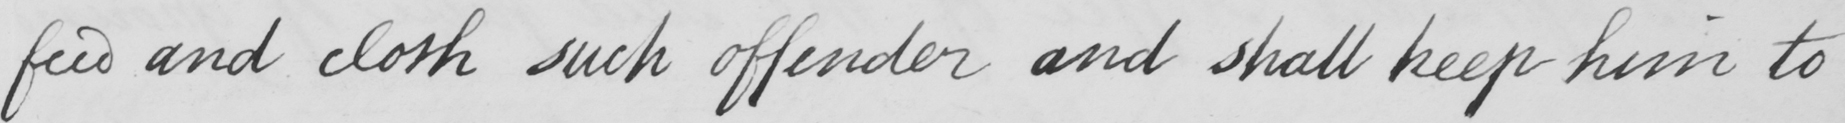Transcribe the text shown in this historical manuscript line. feed and cloth such offender and shall keep him to 